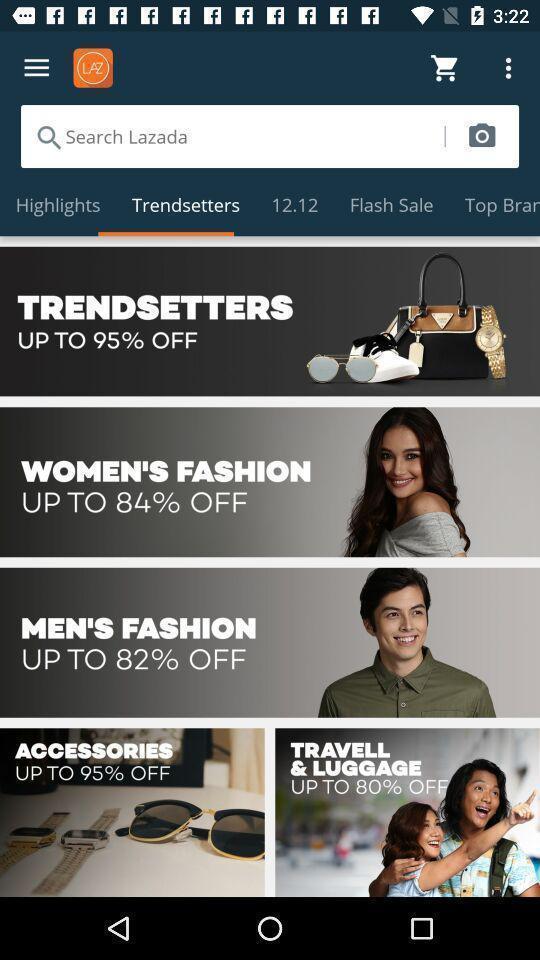Give me a narrative description of this picture. Shopping application displayed trend setters page and other options. 